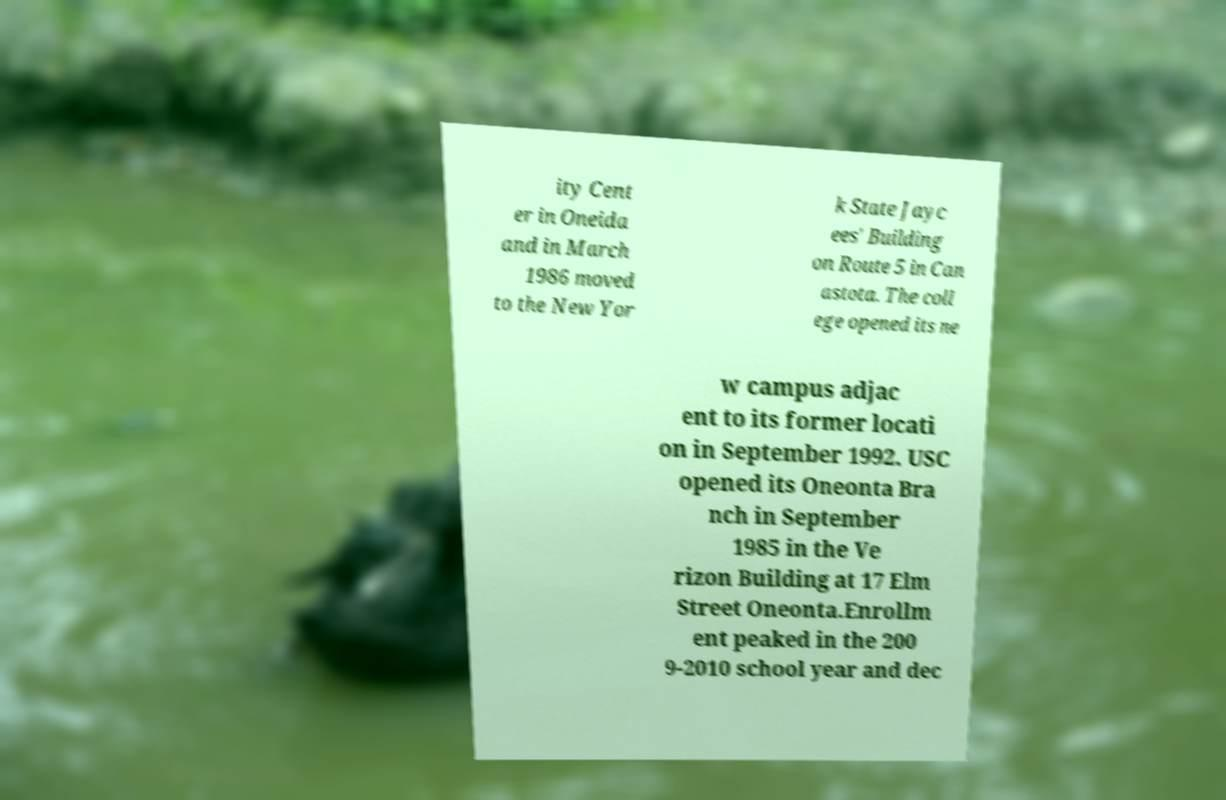Could you extract and type out the text from this image? ity Cent er in Oneida and in March 1986 moved to the New Yor k State Jayc ees' Building on Route 5 in Can astota. The coll ege opened its ne w campus adjac ent to its former locati on in September 1992. USC opened its Oneonta Bra nch in September 1985 in the Ve rizon Building at 17 Elm Street Oneonta.Enrollm ent peaked in the 200 9-2010 school year and dec 